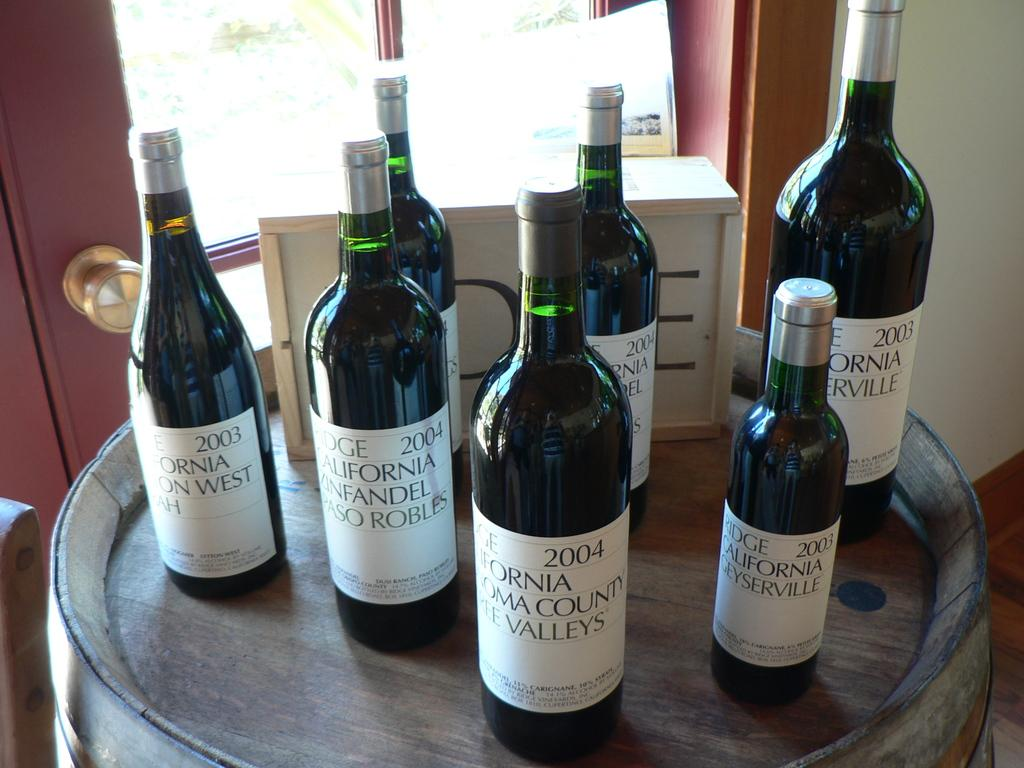<image>
Give a short and clear explanation of the subsequent image. Several bottles of wine from 2003 to 2004 are on a barrel. 